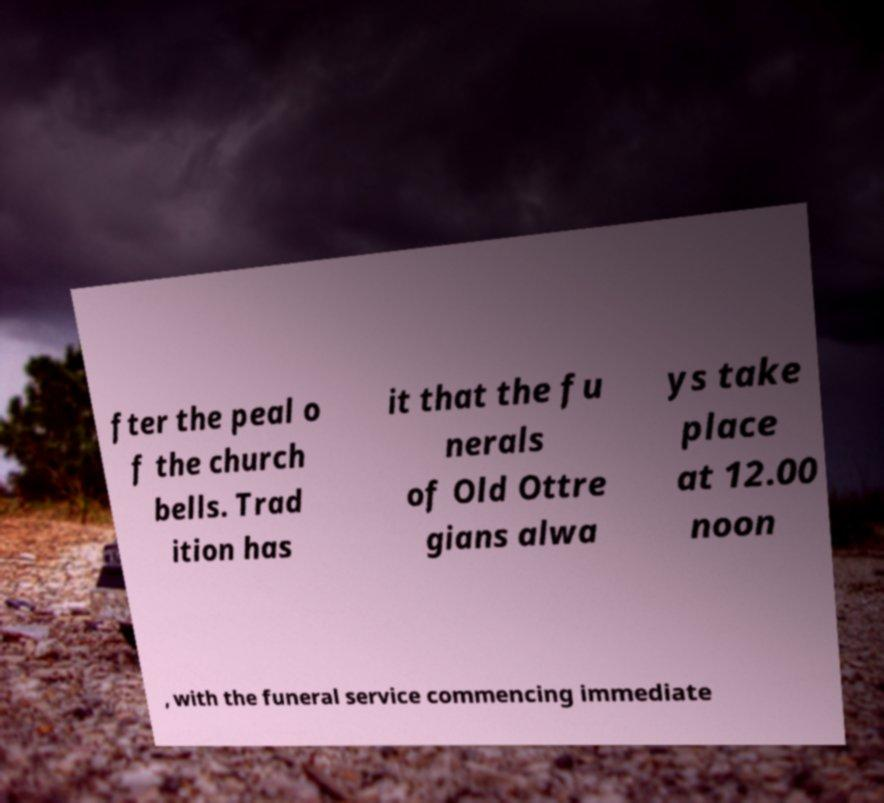What messages or text are displayed in this image? I need them in a readable, typed format. fter the peal o f the church bells. Trad ition has it that the fu nerals of Old Ottre gians alwa ys take place at 12.00 noon , with the funeral service commencing immediate 